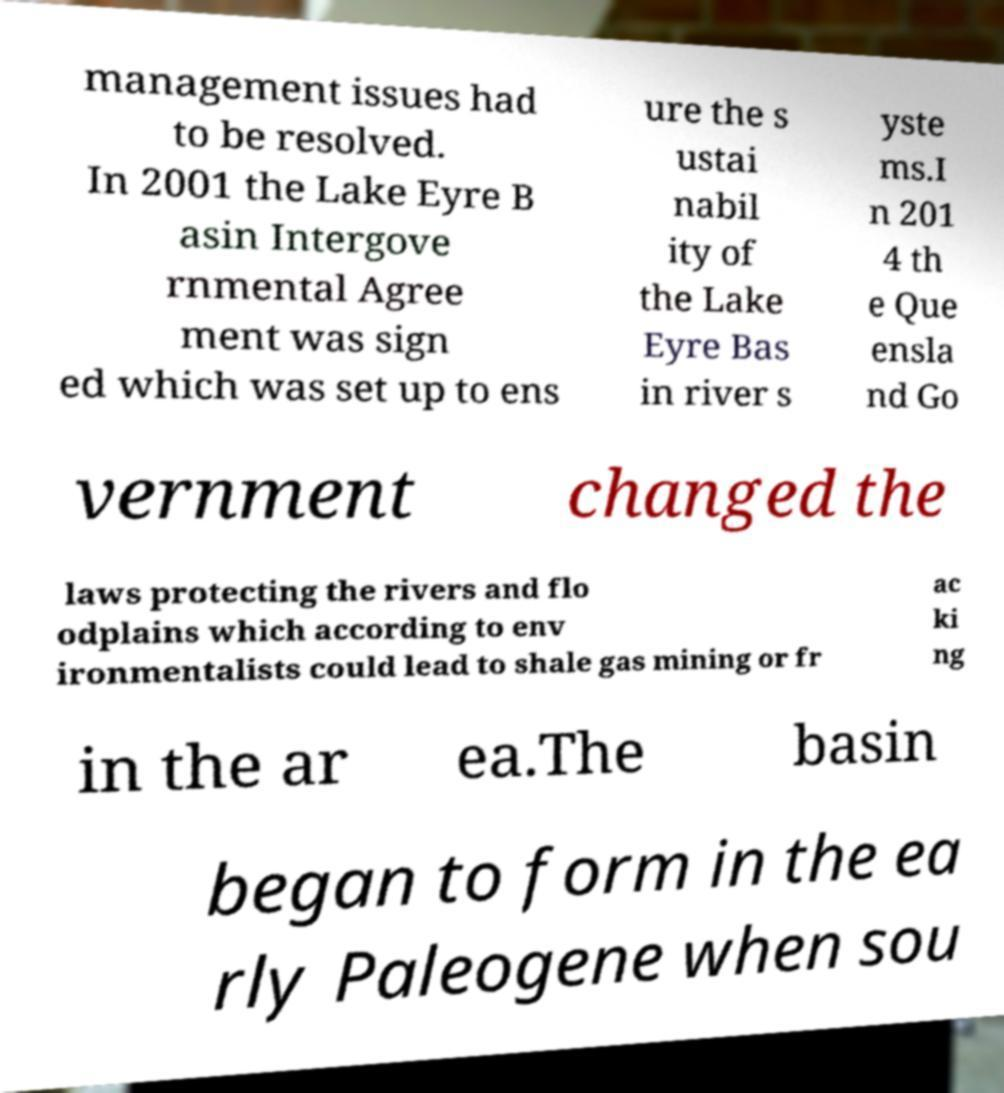Could you extract and type out the text from this image? management issues had to be resolved. In 2001 the Lake Eyre B asin Intergove rnmental Agree ment was sign ed which was set up to ens ure the s ustai nabil ity of the Lake Eyre Bas in river s yste ms.I n 201 4 th e Que ensla nd Go vernment changed the laws protecting the rivers and flo odplains which according to env ironmentalists could lead to shale gas mining or fr ac ki ng in the ar ea.The basin began to form in the ea rly Paleogene when sou 